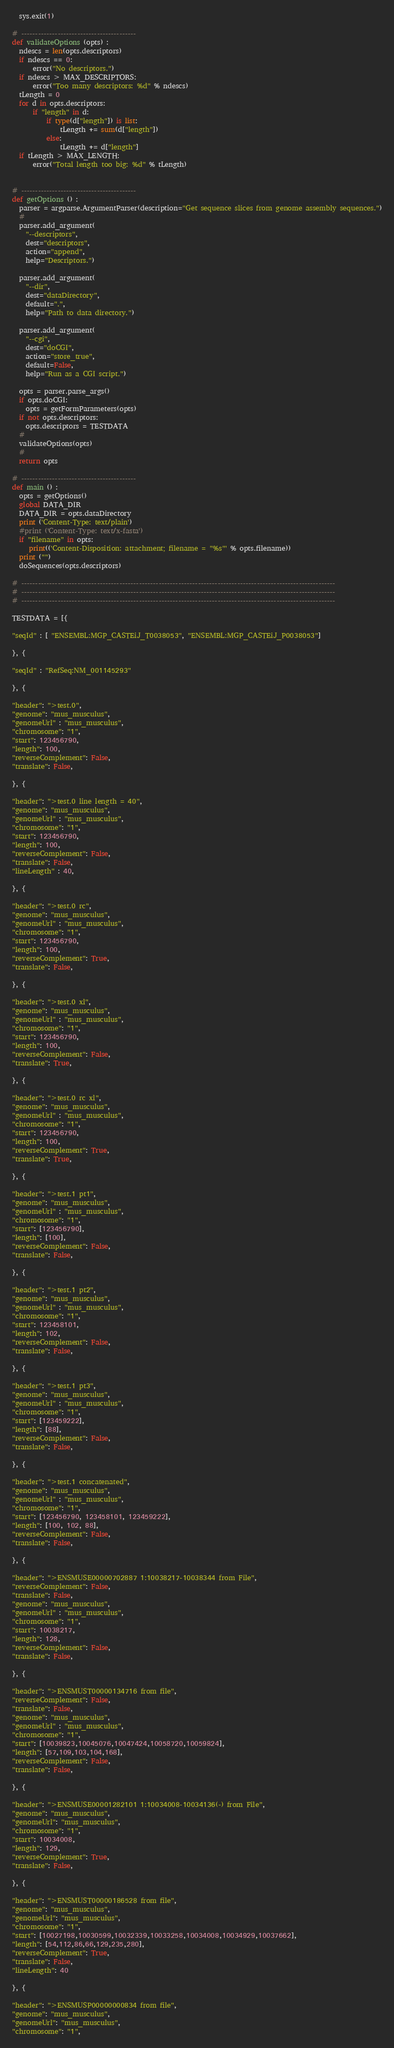Convert code to text. <code><loc_0><loc_0><loc_500><loc_500><_Python_>  sys.exit(1)

# -----------------------------------------
def validateOptions (opts) :
  ndescs = len(opts.descriptors)
  if ndescs == 0:
      error("No descriptors.")
  if ndescs > MAX_DESCRIPTORS:
      error("Too many descriptors: %d" % ndescs)
  tLength = 0
  for d in opts.descriptors:
      if "length" in d:
          if type(d["length"]) is list:
              tLength += sum(d["length"])
          else:
              tLength += d["length"]
  if tLength > MAX_LENGTH:
      error("Total length too big: %d" % tLength)
  

# -----------------------------------------
def getOptions () :
  parser = argparse.ArgumentParser(description="Get sequence slices from genome assembly sequences.")
  #
  parser.add_argument(
    "--descriptors",
    dest="descriptors",
    action="append",
    help="Descriptors.")

  parser.add_argument(
    "--dir",
    dest="dataDirectory",
    default=".",
    help="Path to data directory.")

  parser.add_argument(
    "--cgi",
    dest="doCGI",
    action="store_true",
    default=False,
    help="Run as a CGI script.")

  opts = parser.parse_args()
  if opts.doCGI:
    opts = getFormParameters(opts)
  if not opts.descriptors:
    opts.descriptors = TESTDATA
  #
  validateOptions(opts)
  #
  return opts

# -----------------------------------------
def main () :
  opts = getOptions()
  global DATA_DIR
  DATA_DIR = opts.dataDirectory
  print ('Content-Type: text/plain')
  #print ('Content-Type: text/x-fasta')
  if "filename" in opts:
     print(('Content-Disposition: attachment; filename = "%s"' % opts.filename))
  print ("")
  doSequences(opts.descriptors)

# ----------------------------------------------------------------------------------------------------------------
# ----------------------------------------------------------------------------------------------------------------
# ----------------------------------------------------------------------------------------------------------------

TESTDATA = [{

"seqId" : [ "ENSEMBL:MGP_CASTEiJ_T0038053", "ENSEMBL:MGP_CASTEiJ_P0038053"]

}, {

"seqId" : "RefSeq:NM_001145293"

}, {

"header": ">test.0",
"genome": "mus_musculus",
"genomeUrl" : "mus_musculus",
"chromosome": "1",
"start": 123456790,
"length": 100,
"reverseComplement": False,
"translate": False,

}, {

"header": ">test.0 line length = 40",
"genome": "mus_musculus",
"genomeUrl" : "mus_musculus",
"chromosome": "1",
"start": 123456790,
"length": 100,
"reverseComplement": False,
"translate": False,
"lineLength" : 40,

}, {

"header": ">test.0 rc",
"genome": "mus_musculus",
"genomeUrl" : "mus_musculus",
"chromosome": "1",
"start": 123456790,
"length": 100,
"reverseComplement": True,
"translate": False,

}, {

"header": ">test.0 xl",
"genome": "mus_musculus",
"genomeUrl" : "mus_musculus",
"chromosome": "1",
"start": 123456790,
"length": 100,
"reverseComplement": False,
"translate": True,

}, {

"header": ">test.0 rc xl",
"genome": "mus_musculus",
"genomeUrl" : "mus_musculus",
"chromosome": "1",
"start": 123456790,
"length": 100,
"reverseComplement": True,
"translate": True,

}, {

"header": ">test.1 pt1",
"genome": "mus_musculus",
"genomeUrl" : "mus_musculus",
"chromosome": "1",
"start": [123456790],
"length": [100],
"reverseComplement": False,
"translate": False,

}, {

"header": ">test.1 pt2",
"genome": "mus_musculus",
"genomeUrl" : "mus_musculus",
"chromosome": "1",
"start": 123458101,
"length": 102,
"reverseComplement": False,
"translate": False,

}, {

"header": ">test.1 pt3",
"genome": "mus_musculus",
"genomeUrl" : "mus_musculus",
"chromosome": "1",
"start": [123459222],
"length": [88],
"reverseComplement": False,
"translate": False,

}, {

"header": ">test.1 concatenated",
"genome": "mus_musculus",
"genomeUrl" : "mus_musculus",
"chromosome": "1",
"start": [123456790, 123458101, 123459222],
"length": [100, 102, 88],
"reverseComplement": False,
"translate": False,

}, {

"header": ">ENSMUSE00000702887 1:10038217-10038344 from File",
"reverseComplement": False,
"translate": False,
"genome": "mus_musculus",
"genomeUrl" : "mus_musculus",
"chromosome": "1",
"start": 10038217,
"length": 128,
"reverseComplement": False,
"translate": False,

}, {

"header": ">ENSMUST00000134716 from file",
"reverseComplement": False,
"translate": False,
"genome": "mus_musculus",
"genomeUrl" : "mus_musculus",
"chromosome": "1",
"start": [10039823,10045076,10047424,10058720,10059824],
"length": [57,109,103,104,168],
"reverseComplement": False,
"translate": False,

}, {

"header": ">ENSMUSE00001282101 1:10034008-10034136(-) from File",
"genome": "mus_musculus",
"genomeUrl": "mus_musculus",
"chromosome": "1",
"start": 10034008,
"length": 129,
"reverseComplement": True,
"translate": False,

}, {

"header": ">ENSMUST00000186528 from file",
"genome": "mus_musculus",
"genomeUrl": "mus_musculus",
"chromosome": "1",
"start": [10027198,10030599,10032339,10033258,10034008,10034929,10037662],
"length": [54,112,86,66,129,235,280],
"reverseComplement": True,
"translate": False,
"lineLength": 40

}, {

"header": ">ENSMUSP00000000834 from file",
"genome": "mus_musculus",
"genomeUrl": "mus_musculus",
"chromosome": "1",</code> 